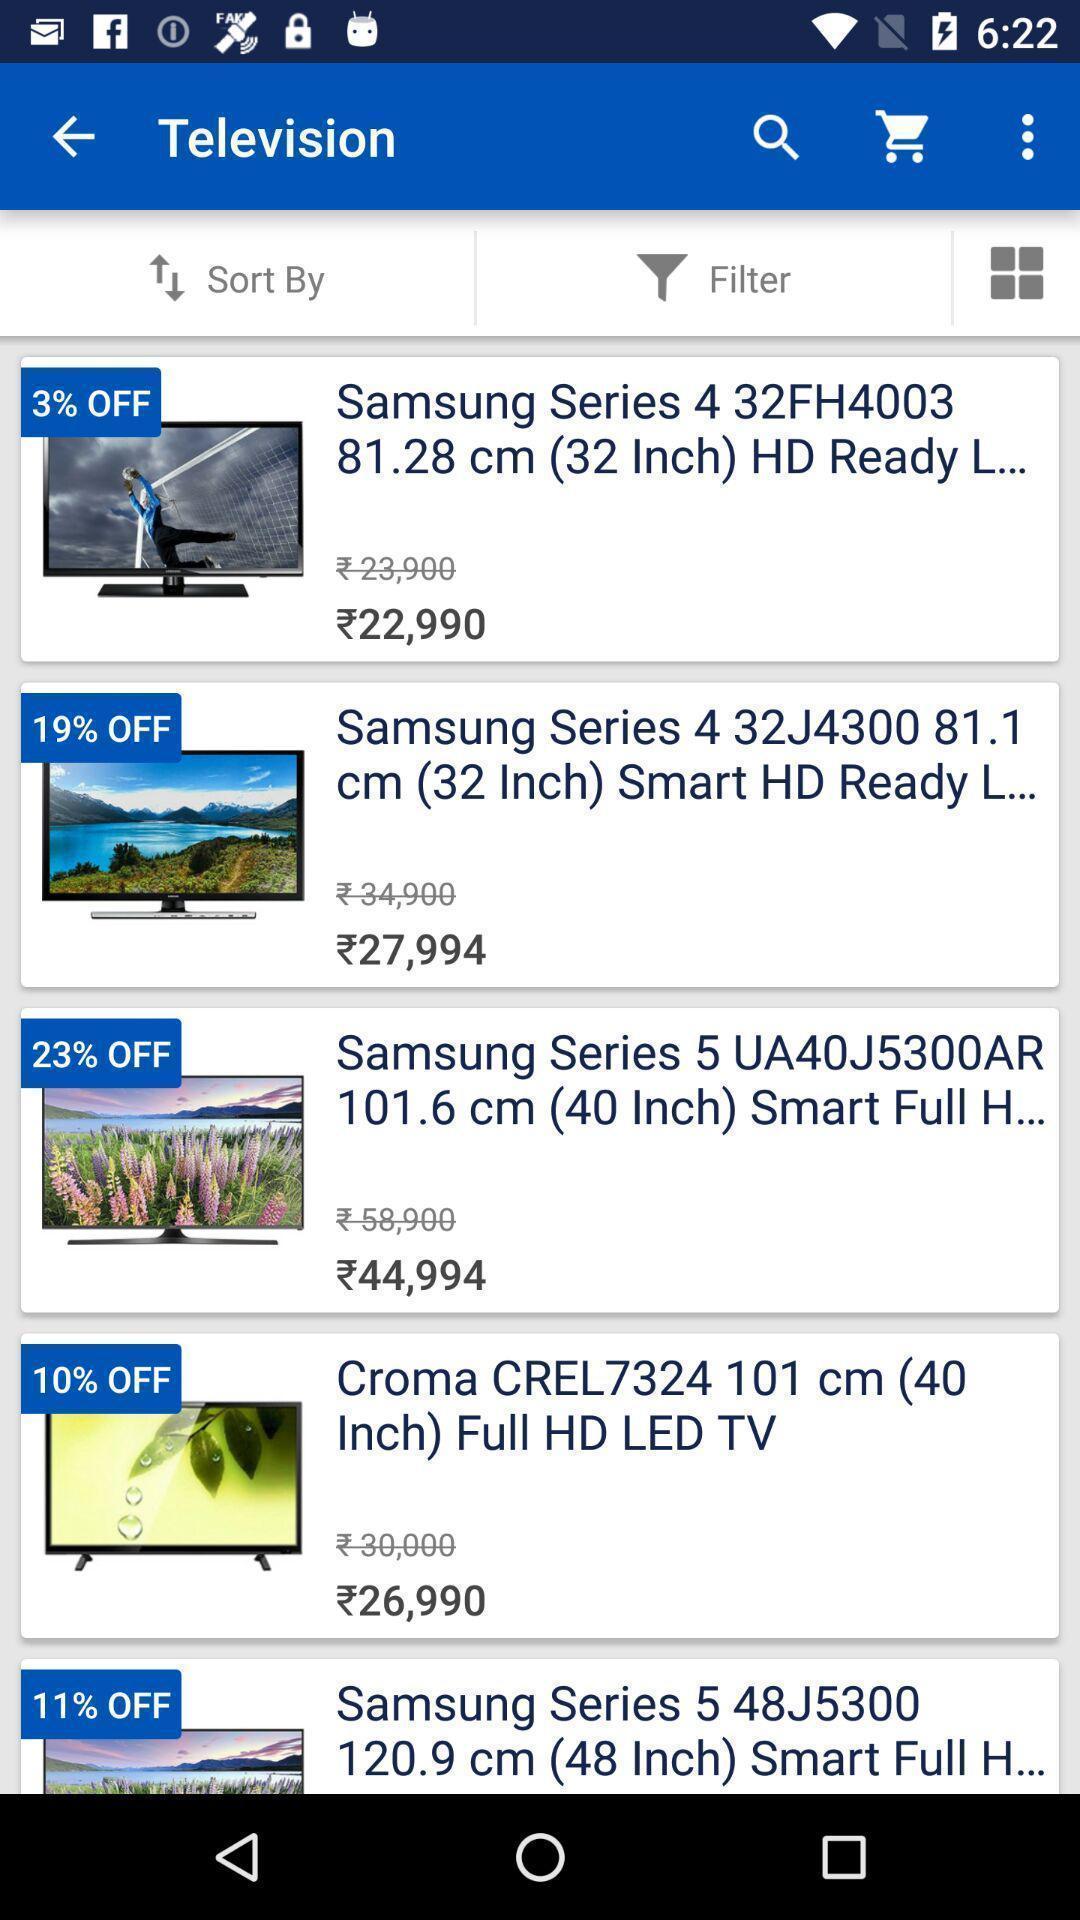Give me a summary of this screen capture. Page displaying a list of products in a shopping app. 